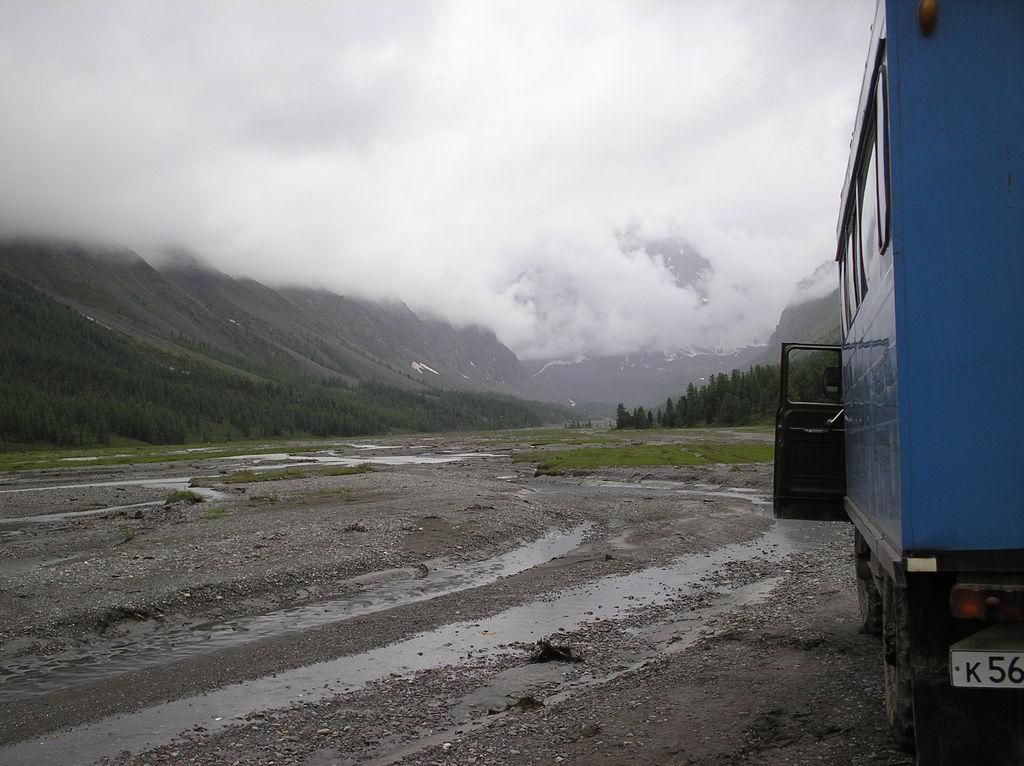What is the main subject in the foreground of the image? There is a vehicle on the road in the foreground. What type of vegetation can be seen in the foreground? There is grass in the foreground. What can be seen in the background of the image? There are trees, mountains, fog, and the sky visible in the background. Can you describe the weather condition in the image? The image might have been taken on a rainy day, as indicated by the presence of fog. What type of coal can be seen in the image? There is no coal present in the image. How many crows are sitting on the vehicle in the image? There are no crows present in the image. 